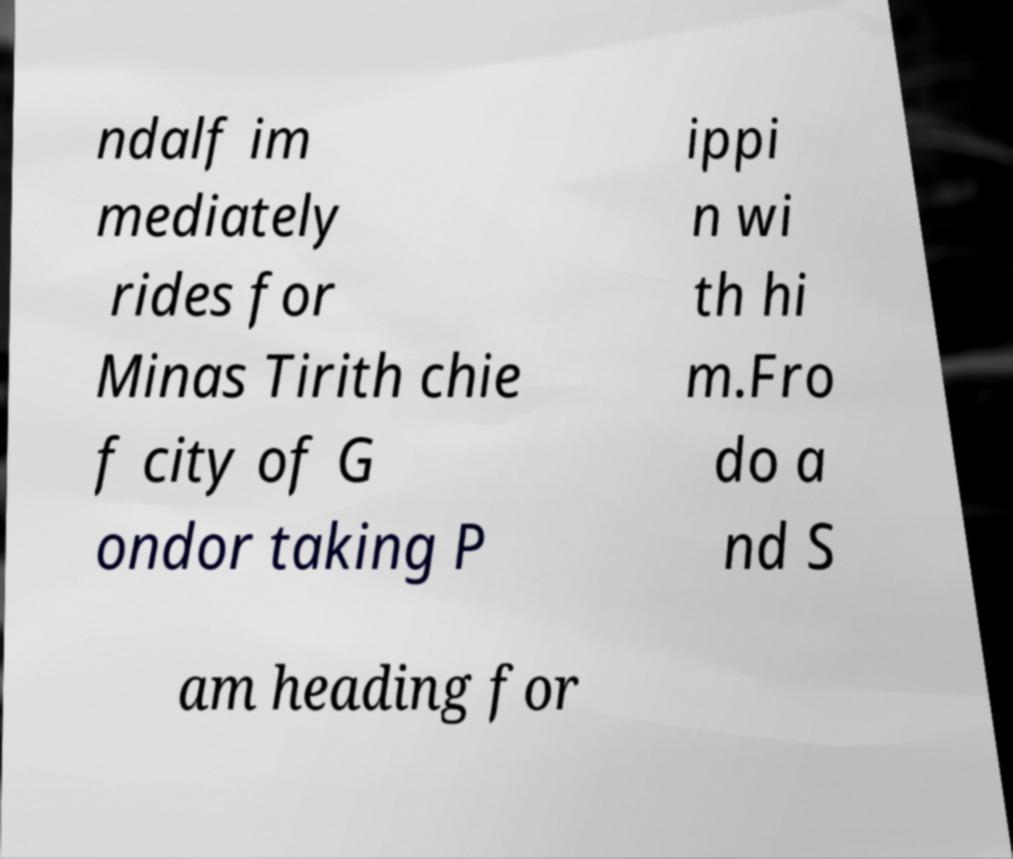Please read and relay the text visible in this image. What does it say? ndalf im mediately rides for Minas Tirith chie f city of G ondor taking P ippi n wi th hi m.Fro do a nd S am heading for 